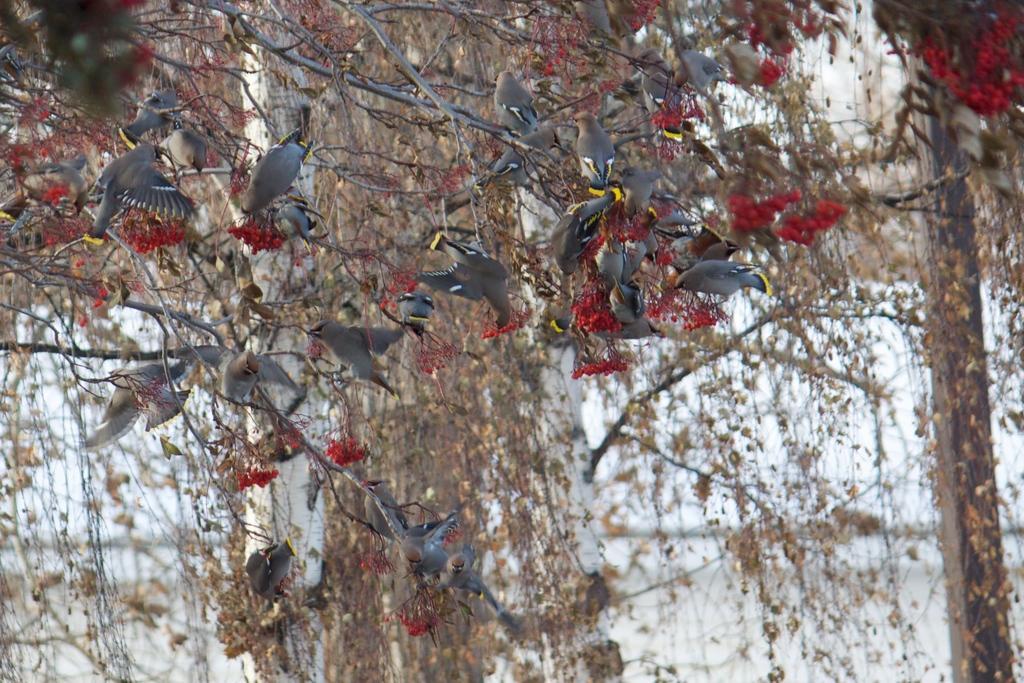Could you give a brief overview of what you see in this image? In this image, we can see some trees. Among them, we can see some birds on one of the trees. We can see a pole on the right. We can see the sky. 